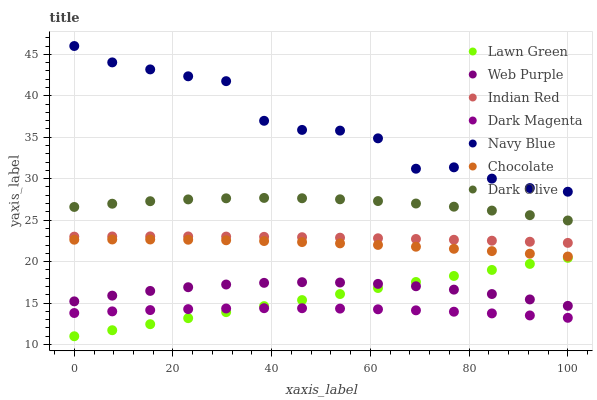Does Dark Magenta have the minimum area under the curve?
Answer yes or no. Yes. Does Navy Blue have the maximum area under the curve?
Answer yes or no. Yes. Does Navy Blue have the minimum area under the curve?
Answer yes or no. No. Does Dark Magenta have the maximum area under the curve?
Answer yes or no. No. Is Lawn Green the smoothest?
Answer yes or no. Yes. Is Navy Blue the roughest?
Answer yes or no. Yes. Is Dark Magenta the smoothest?
Answer yes or no. No. Is Dark Magenta the roughest?
Answer yes or no. No. Does Lawn Green have the lowest value?
Answer yes or no. Yes. Does Dark Magenta have the lowest value?
Answer yes or no. No. Does Navy Blue have the highest value?
Answer yes or no. Yes. Does Dark Magenta have the highest value?
Answer yes or no. No. Is Dark Olive less than Navy Blue?
Answer yes or no. Yes. Is Chocolate greater than Lawn Green?
Answer yes or no. Yes. Does Web Purple intersect Lawn Green?
Answer yes or no. Yes. Is Web Purple less than Lawn Green?
Answer yes or no. No. Is Web Purple greater than Lawn Green?
Answer yes or no. No. Does Dark Olive intersect Navy Blue?
Answer yes or no. No. 